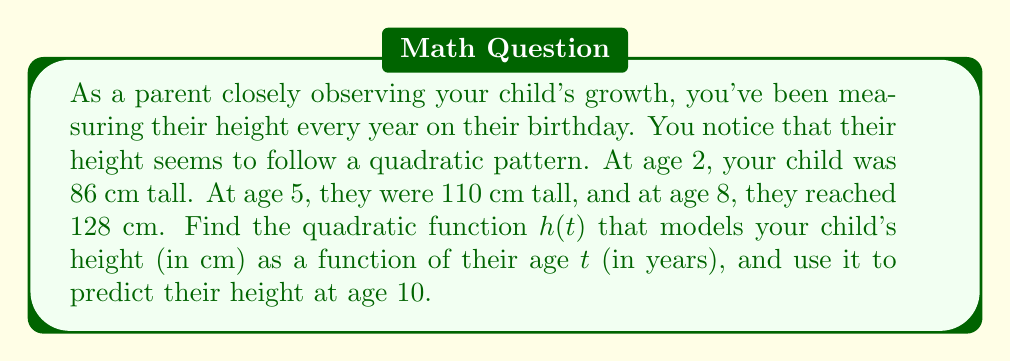Could you help me with this problem? Let's approach this step-by-step:

1) The general form of a quadratic function is $h(t) = at^2 + bt + c$, where $a$, $b$, and $c$ are constants we need to determine.

2) We have three data points:
   $(2, 86)$, $(5, 110)$, and $(8, 128)$

3) Substituting these into our general form:
   $86 = 4a + 2b + c$
   $110 = 25a + 5b + c$
   $128 = 64a + 8b + c$

4) Subtracting the first equation from the second:
   $24 = 21a + 3b$

5) Subtracting the first equation from the third:
   $42 = 60a + 6b$

6) Multiplying the equation from step 4 by 2:
   $48 = 42a + 6b$

7) Subtracting this from the equation in step 5:
   $-6 = 18a$
   $a = -\frac{1}{3}$

8) Substituting this back into the equation from step 4:
   $24 = 21(-\frac{1}{3}) + 3b$
   $24 = -7 + 3b$
   $31 = 3b$
   $b = \frac{31}{3}$

9) Now we can substitute $a$ and $b$ into our original equation:
   $86 = 4(-\frac{1}{3}) + 2(\frac{31}{3}) + c$
   $86 = -\frac{4}{3} + \frac{62}{3} + c$
   $86 = \frac{58}{3} + c$
   $c = 86 - \frac{58}{3} = \frac{200}{3}$

10) Therefore, our quadratic function is:
    $h(t) = -\frac{1}{3}t^2 + \frac{31}{3}t + \frac{200}{3}$

11) To predict the height at age 10, we substitute $t = 10$:
    $h(10) = -\frac{1}{3}(10)^2 + \frac{31}{3}(10) + \frac{200}{3}$
    $= -\frac{100}{3} + \frac{310}{3} + \frac{200}{3}$
    $= \frac{410}{3}$
    $\approx 136.67$ cm
Answer: The quadratic function modeling the child's height is $h(t) = -\frac{1}{3}t^2 + \frac{31}{3}t + \frac{200}{3}$, where $h$ is the height in cm and $t$ is the age in years. The predicted height at age 10 is approximately 136.67 cm. 